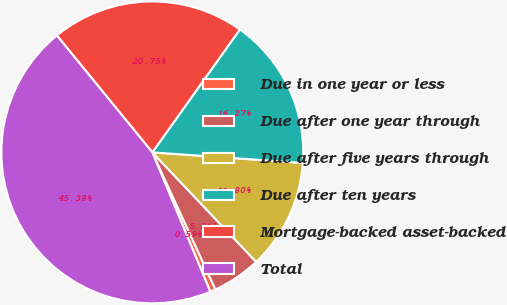Convert chart to OTSL. <chart><loc_0><loc_0><loc_500><loc_500><pie_chart><fcel>Due in one year or less<fcel>Due after one year through<fcel>Due after five years through<fcel>Due after ten years<fcel>Mortgage-backed asset-backed<fcel>Total<nl><fcel>0.59%<fcel>5.21%<fcel>11.8%<fcel>16.27%<fcel>20.75%<fcel>45.38%<nl></chart> 